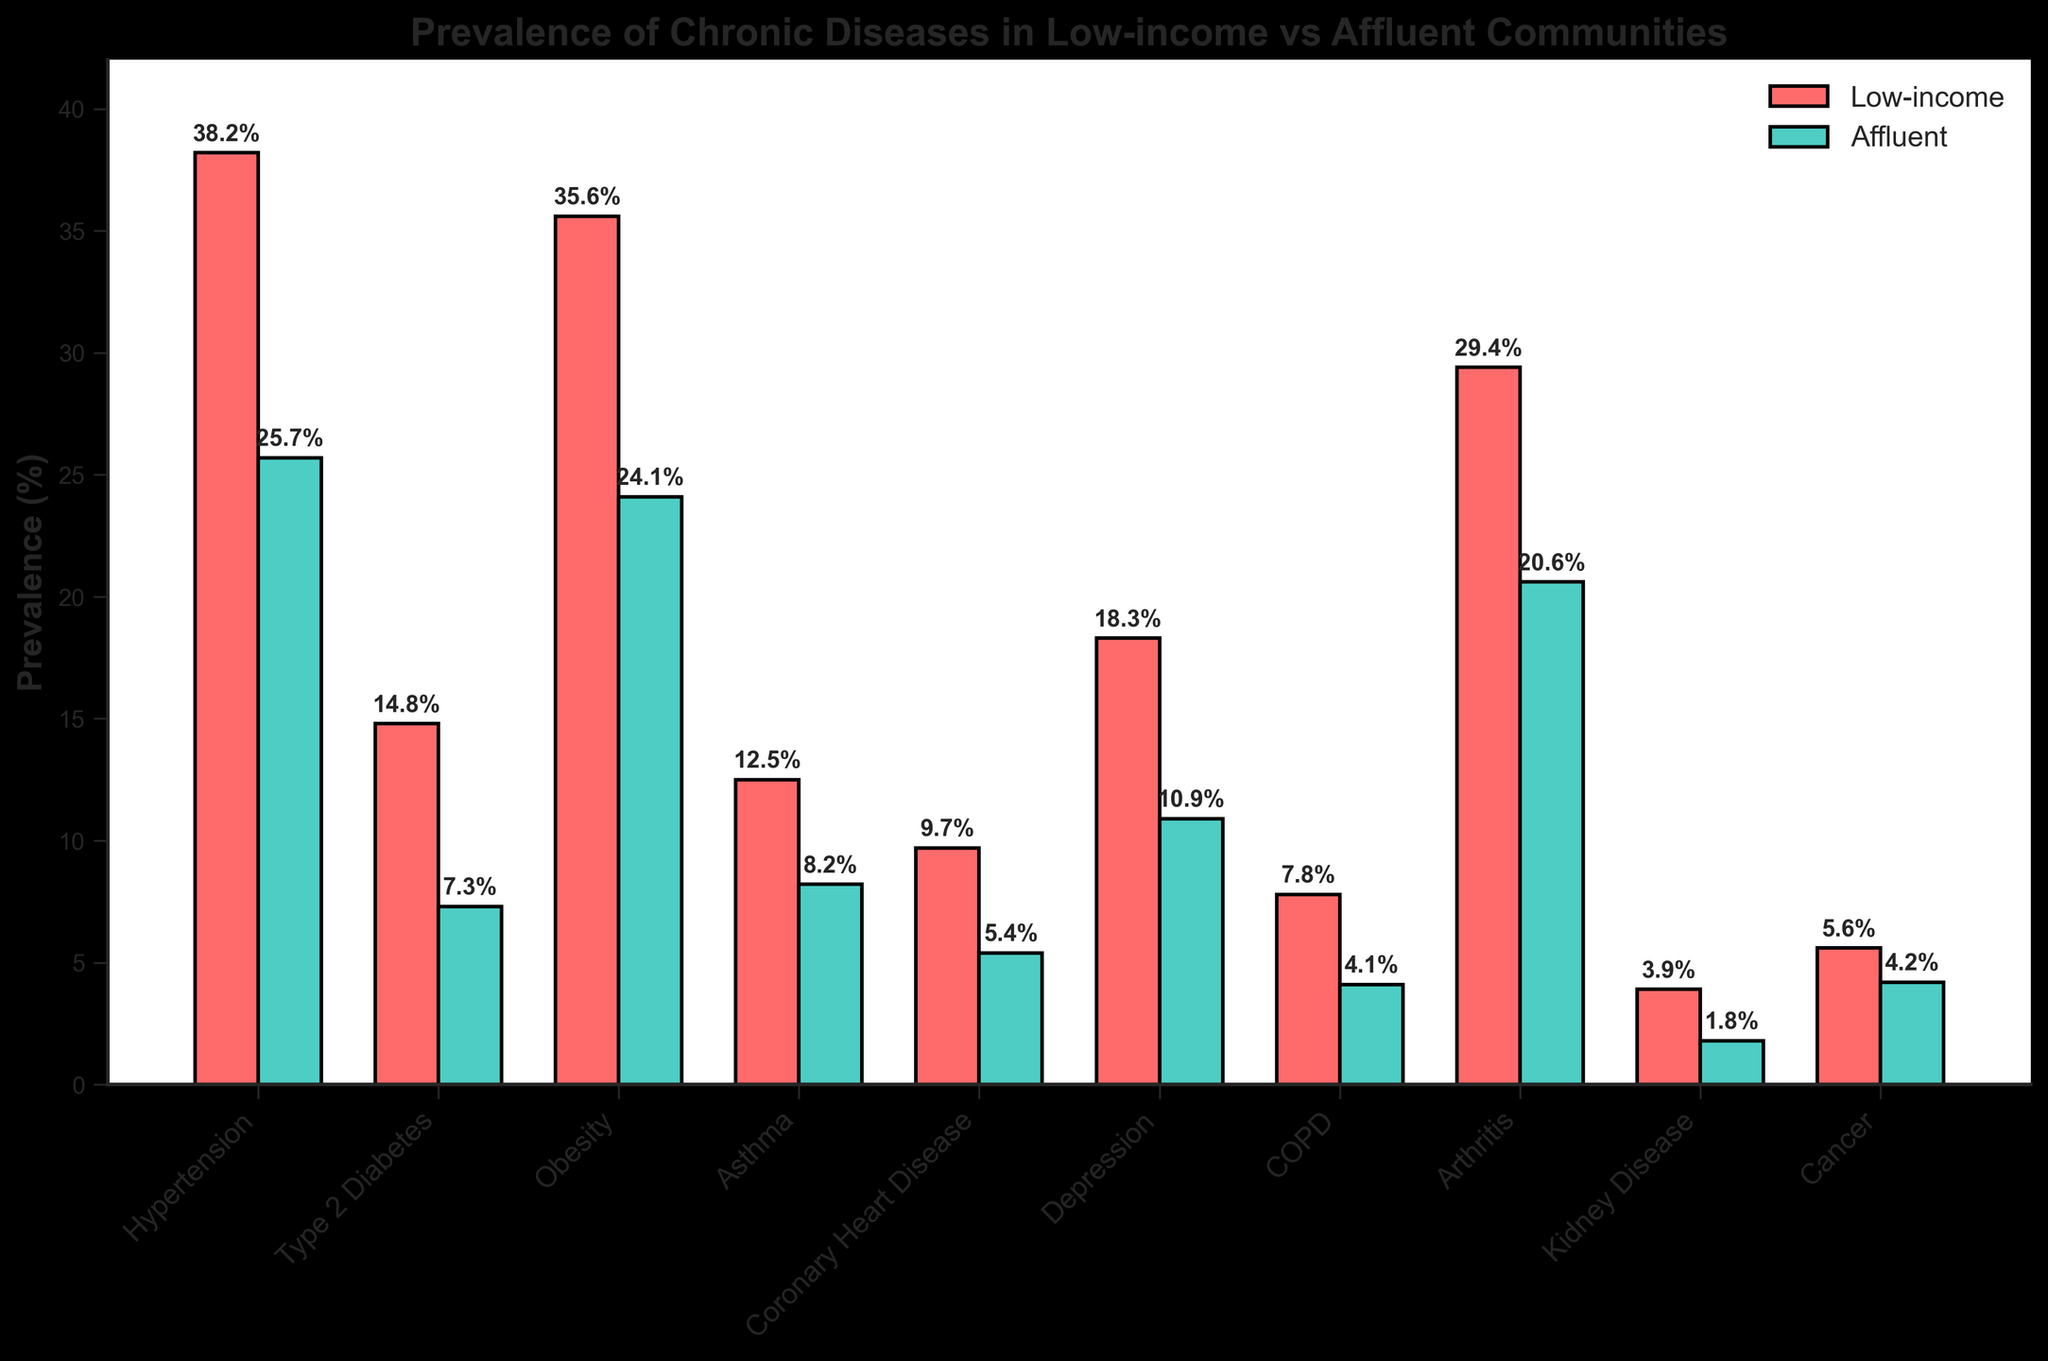Which chronic disease has the highest prevalence in low-income communities? The bar representing Hypertension in low-income communities is the tallest among all other diseases.
Answer: Hypertension Which chronic disease has the smallest difference in prevalence between low-income and affluent communities? By observing the height of the bars, Cancer has a difference of 5.6% (low-income) - 4.2% (affluent) = 1.4%, which is the smallest difference among all diseases.
Answer: Cancer How much higher is the prevalence of Type 2 Diabetes in low-income communities compared to affluent neighborhoods? The prevalence of Type 2 Diabetes is 14.8% in low-income communities and 7.3% in affluent neighborhoods. The difference is 14.8% - 7.3% = 7.5%.
Answer: 7.5% What is the average prevalence of Depression in both communities? The prevalence for Depression is 18.3% in low-income communities and 10.9% in affluent neighborhoods. The average is (18.3 + 10.9) / 2 = 14.6%.
Answer: 14.6% Which disease has the most significant visual discrepancy in prevalence between the two communities? Comparing the visual lengths of the bars, Hypertension shows the most significant discrepancy, with a more considerable difference in bar height between the red and green bars.
Answer: Hypertension What is the combined prevalence of Obesity and Arthritis in low-income communities? The prevalence of Obesity in low-income communities is 35.6%, and for Arthritis, it is 29.4%. The combined prevalence is 35.6% + 29.4% = 65%.
Answer: 65% Which community has a higher prevalence of COPD, and by how much? The prevalence of COPD is 7.8% in low-income communities and 4.1% in affluent communities. The difference is 7.8% - 4.1% = 3.7%. The prevalence is higher in low-income communities.
Answer: Low-income, 3.7% How does the prevalence of Kidney Disease compare between the two communities? The prevalence of Kidney Disease is 3.9% in low-income communities and 1.8% in affluent neighborhoods. It is more prevalent in low-income communities by 3.9% - 1.8% = 2.1%.
Answer: 2.1% Which disease has a greater prevalence in affluent communities compared to low-income, if any? None of the diseases listed have a greater prevalence in affluent communities compared to low-income communities; all diseases are either equally or more prevalent in low-income communities.
Answer: None How does the prevalence of Coronary Heart Disease in low-income communities compare to the prevalence of Depression in affluent neighborhoods? The prevalence of Coronary Heart Disease in low-income communities is 9.7%, and the prevalence of Depression in affluent neighborhoods is 10.9%. Thus, Depression in affluent neighborhoods is higher by 10.9% - 9.7% = 1.2%.
Answer: Depression in affluent communities is higher by 1.2% 